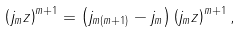Convert formula to latex. <formula><loc_0><loc_0><loc_500><loc_500>\left ( j _ { m } z \right ) ^ { m + 1 } = \left ( j _ { m ( m + 1 ) } - j _ { m } \right ) \left ( j _ { m } z \right ) ^ { m + 1 } ,</formula> 